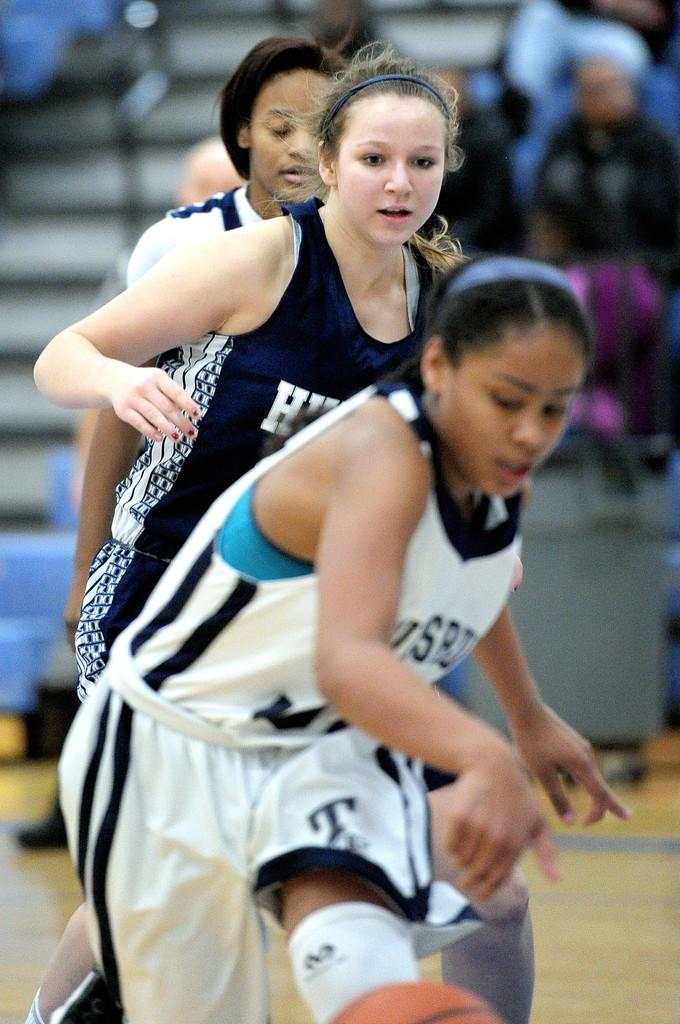What are the people in the image doing? The people in the image are running on the ground. What can be seen in the background of the image? The background of the image appears to be a stadium. Are there any other people in the image besides those running? Yes, there are people sitting on chairs in the image. Where is the hydrant located in the image? There is no hydrant present in the image. What color is the clover that the people are wearing in the image? There is no clover present in the image, and the people are not wearing any. 